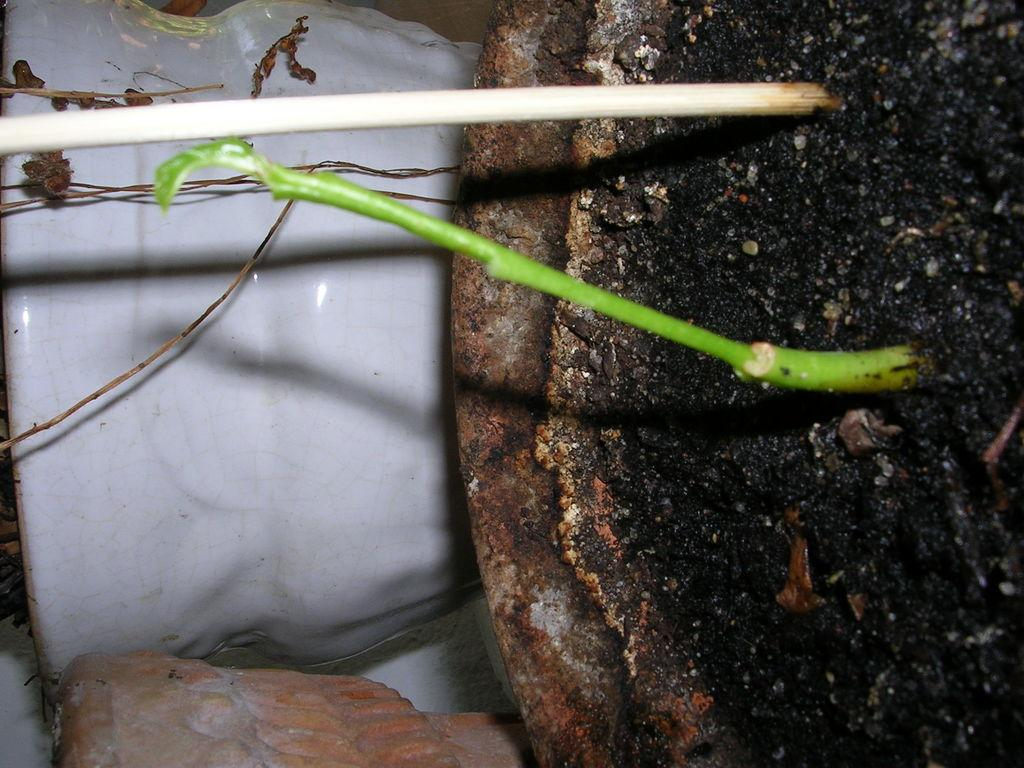What object is present in the image that is typically used for holding plants? There is a flower pot in the image. What can be seen extending from the flower pot in the image? There is a stem in the image. What other object is visible in the image that is not related to the plant? There is a stick in the image. What is the name of the daughter of the person who owns the flower pot in the image? There is no information about the owner of the flower pot or any daughters in the image. 